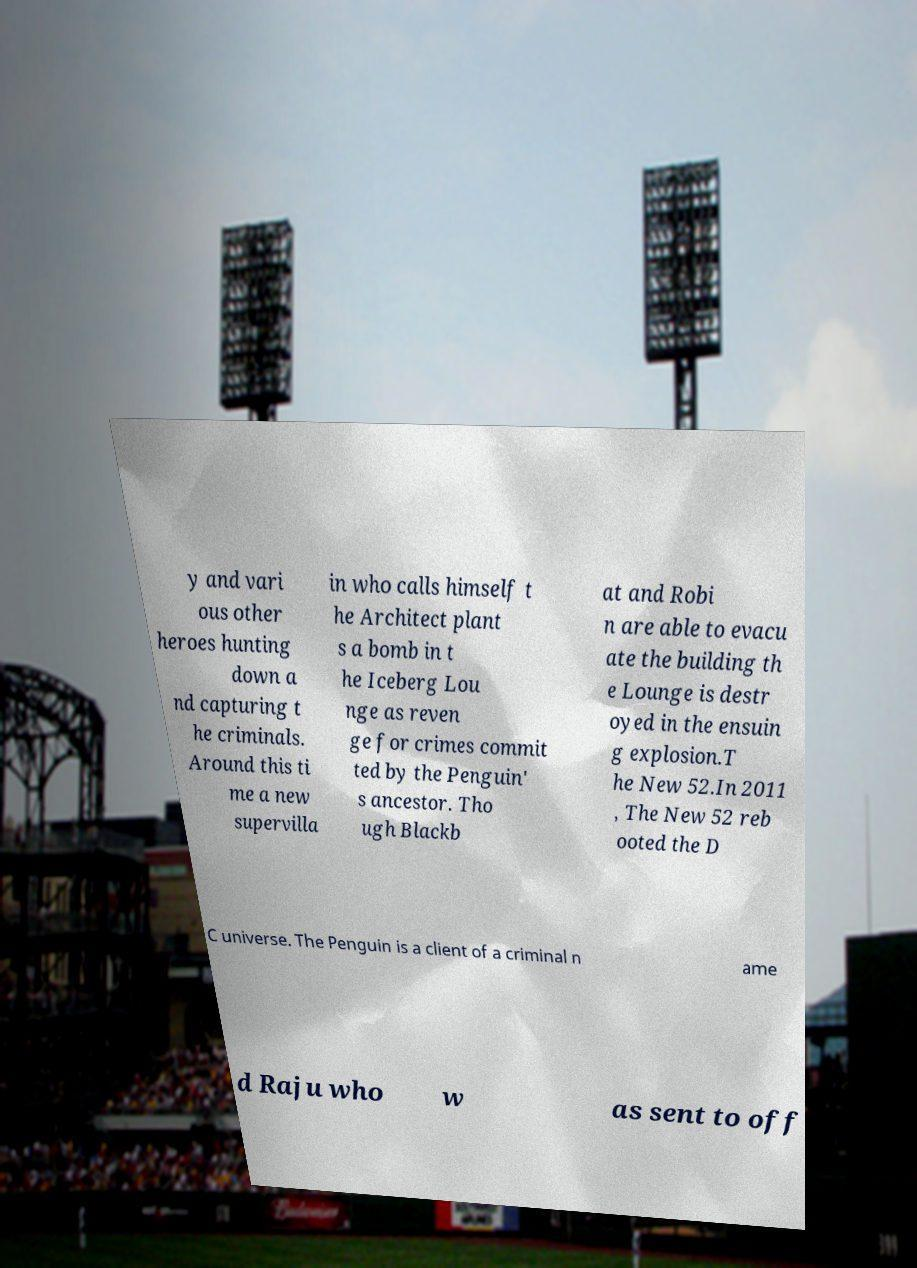I need the written content from this picture converted into text. Can you do that? y and vari ous other heroes hunting down a nd capturing t he criminals. Around this ti me a new supervilla in who calls himself t he Architect plant s a bomb in t he Iceberg Lou nge as reven ge for crimes commit ted by the Penguin' s ancestor. Tho ugh Blackb at and Robi n are able to evacu ate the building th e Lounge is destr oyed in the ensuin g explosion.T he New 52.In 2011 , The New 52 reb ooted the D C universe. The Penguin is a client of a criminal n ame d Raju who w as sent to off 